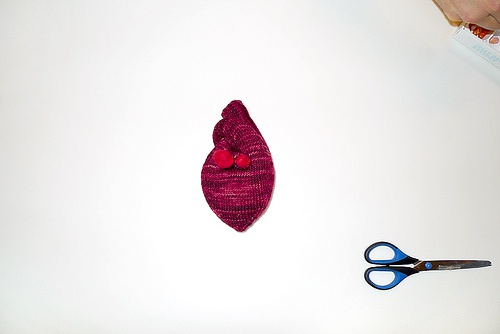Describe the objects in this image and their specific colors. I can see scissors in lightgray, white, black, gray, and blue tones, people in lightgray, tan, and gray tones, and people in lightgray, maroon, brown, and darkgray tones in this image. 